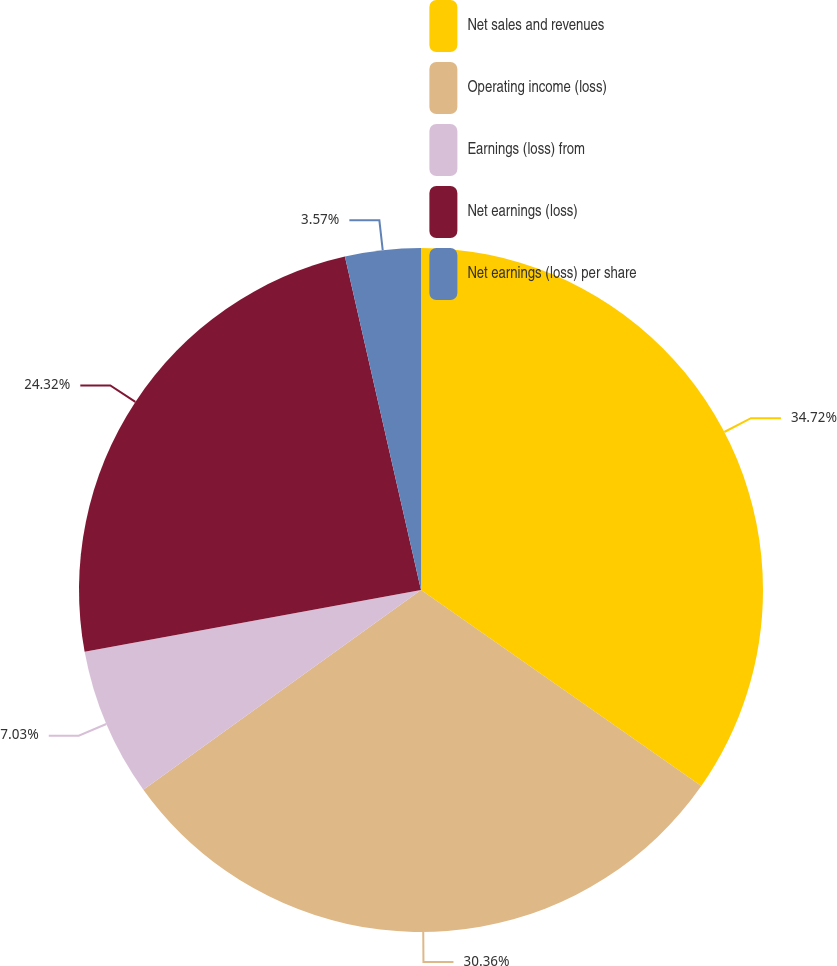Convert chart. <chart><loc_0><loc_0><loc_500><loc_500><pie_chart><fcel>Net sales and revenues<fcel>Operating income (loss)<fcel>Earnings (loss) from<fcel>Net earnings (loss)<fcel>Net earnings (loss) per share<nl><fcel>34.71%<fcel>30.36%<fcel>7.03%<fcel>24.32%<fcel>3.57%<nl></chart> 